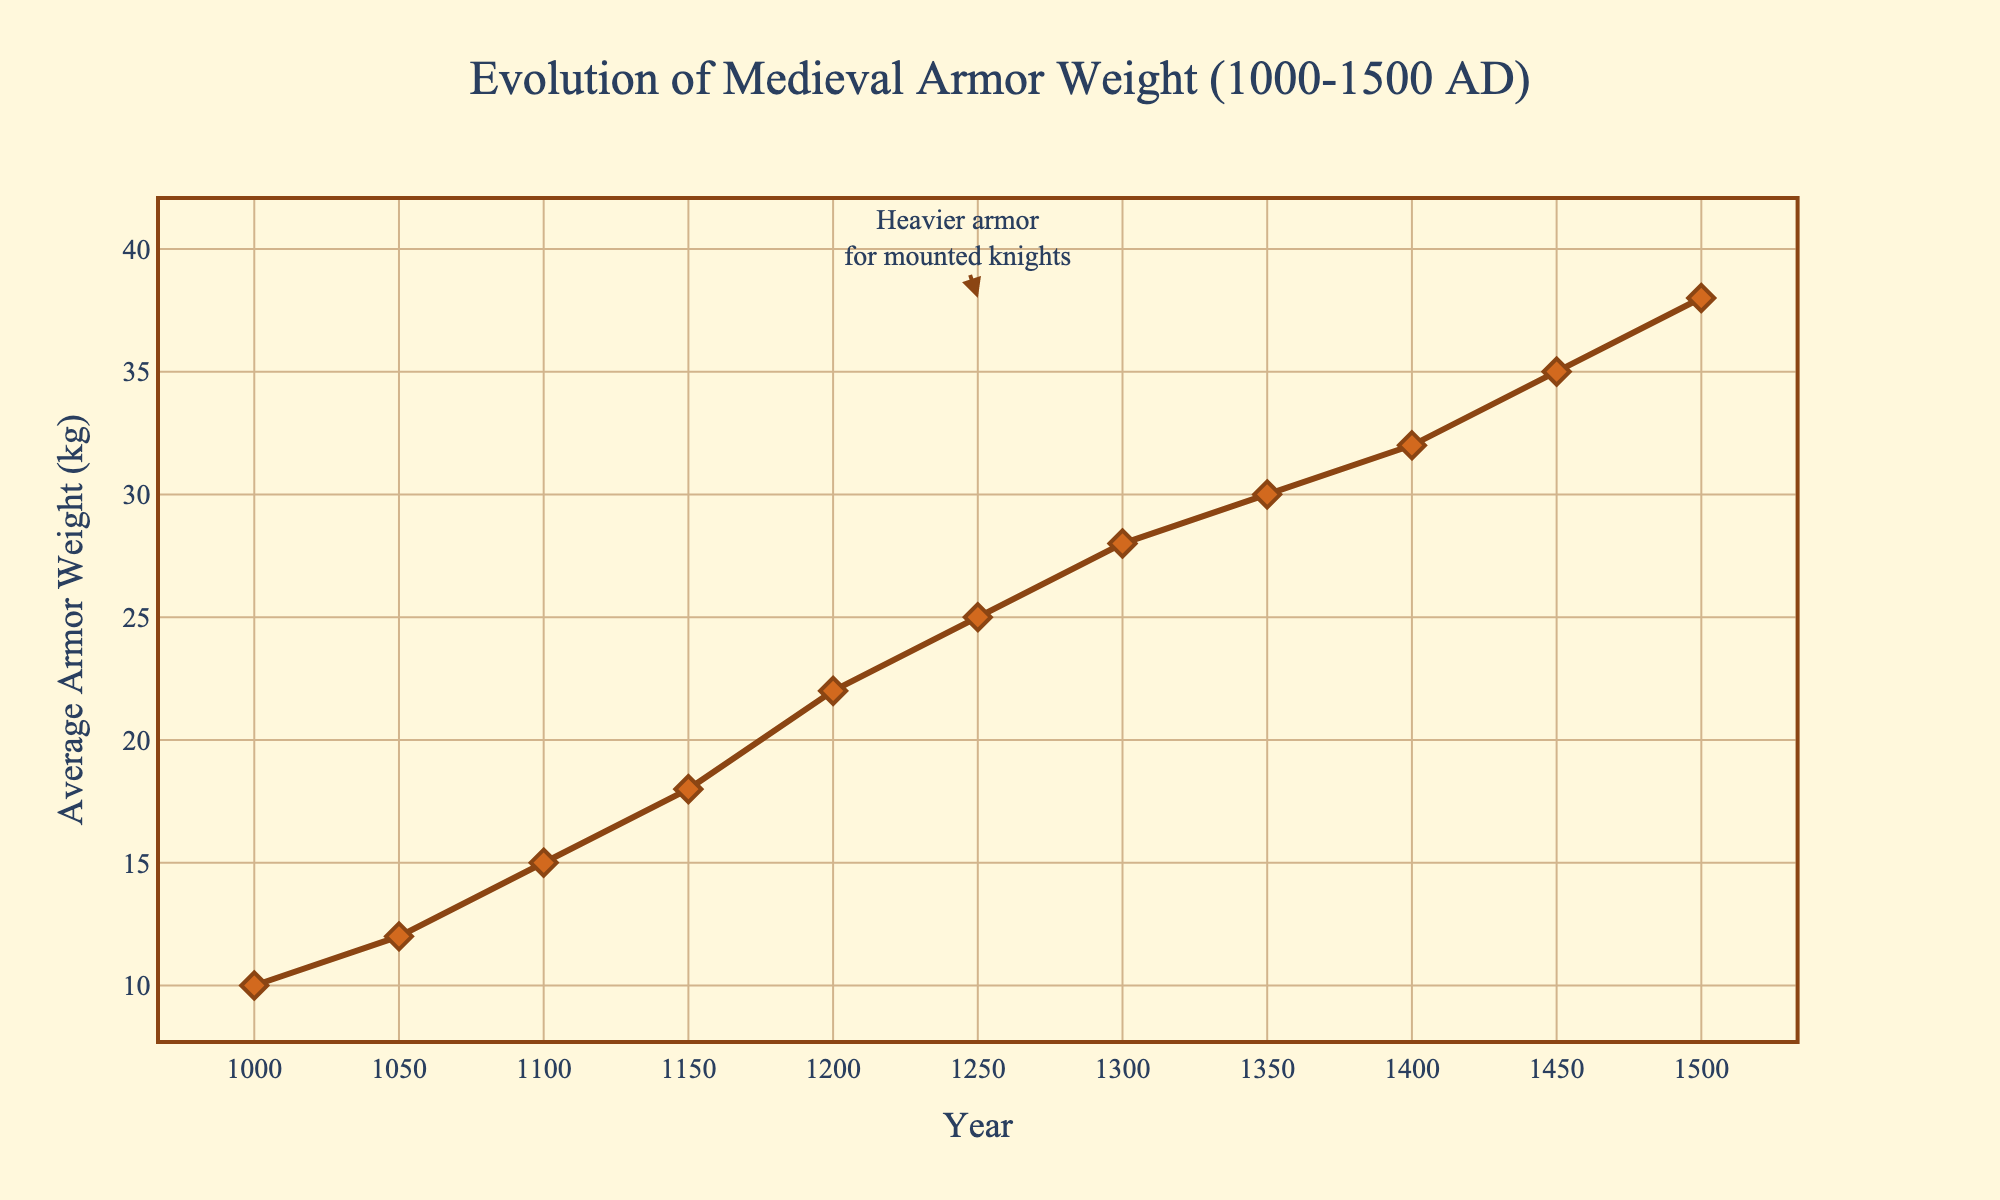What's the weight difference of armor between the year 1500 and the year 1000? To find the weight difference, subtract the weight in the year 1000 (10 kg) from the weight in the year 1500 (38 kg). So, 38 - 10 = 28 kg.
Answer: 28 kg Between which years did the average armor weight increase the most? By examining the chart, the largest increase in weight happens between the years 1400 (32 kg) and 1450 (35 kg), which is a 3 kg increase.
Answer: Between 1400 and 1450 What is the average weight increase per century from 1000 to 1500? To find this, compute the total increase in weight and divide it by the number of centuries. The total increase is from 10 kg in 1000 to 38 kg in 1500, which is 38 - 10 = 28 kg. Since there are 5 centuries, the average increase per century is 28 kg / 5 = 5.6 kg.
Answer: 5.6 kg How long does it take for the armor weight to reach 30 kg starting from 1000 AD? The armor weight reaches 30 kg by the year 1350. From the year 1000 to 1350, it takes 350 years.
Answer: 350 years What visual feature indicates the heaviest armor in the plot? The heaviest armor is indicated by the highest point on the line chart, which is annotated with an arrow pointing at the year 1500 and showing the weight as 38 kg.
Answer: Highest point at year 1500 How does the armor weight change from 1250 to 1300? From the year 1250 (25 kg) to the year 1300 (28 kg), the armor weight increases by 3 kg.
Answer: Increased by 3 kg What period shows the slowest rate of armor weight increase? From the chart, observe the smallest differences between any consecutive points. The slowest rate of increase appears between the years 1400 (32 kg) and 1450 (35 kg), alongside 1450 (35 kg) to 1500 (38 kg), both showing a steady 3 kg increase in 50 years.
Answer: 1400 to 1450 What's the average weight of armor over the period 1000-1200? To calculate the average weight from 1000 to 1200, sum the weights at 1000 (10 kg), 1050 (12 kg), 1100 (15 kg), 1150 (18 kg), and 1200 (22 kg), and then divide by 5. (10 + 12 + 15 + 18 + 22) / 5 = 15.4 kg.
Answer: 15.4 kg Which century sees the largest increase in armor weight compared to the previous century? Check century-over-century increases: From 1000 to 1100, it's 5 kg; 1100 to 1200, it's 7 kg; 1200 to 1300, it's 6 kg; 1300 to 1400, it's 6 kg; 1400 to 1500, it's 6 kg. The largest single century increase is from 1100 to 1200 with 7 kg.
Answer: 12th century 